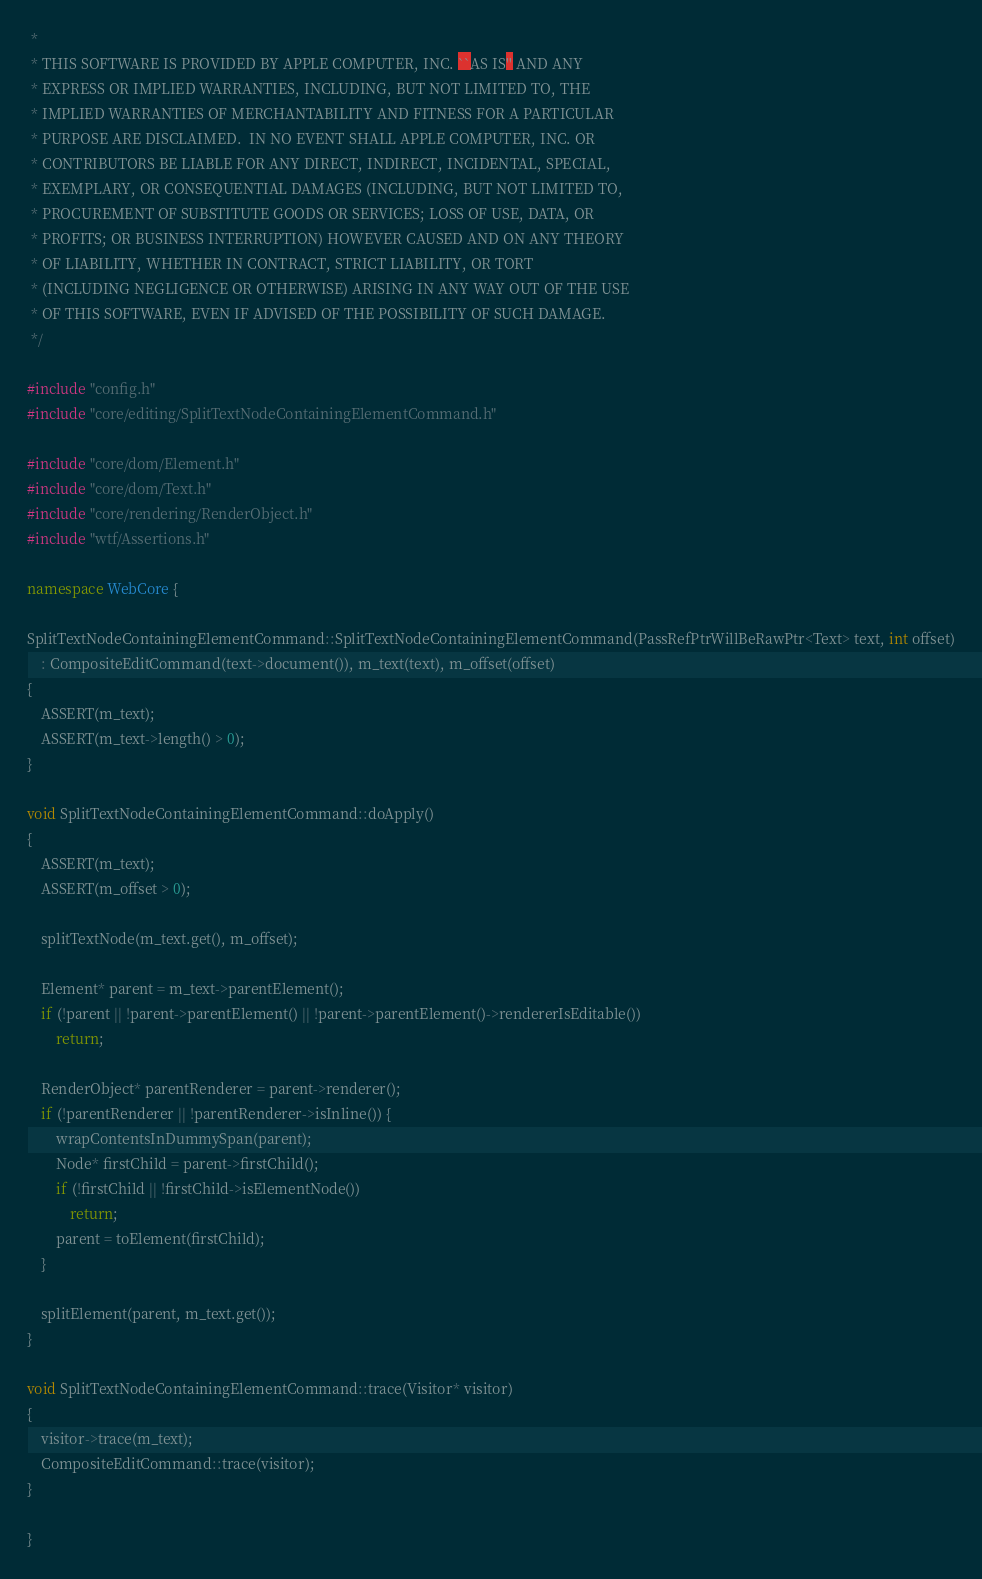<code> <loc_0><loc_0><loc_500><loc_500><_C++_> *
 * THIS SOFTWARE IS PROVIDED BY APPLE COMPUTER, INC. ``AS IS'' AND ANY
 * EXPRESS OR IMPLIED WARRANTIES, INCLUDING, BUT NOT LIMITED TO, THE
 * IMPLIED WARRANTIES OF MERCHANTABILITY AND FITNESS FOR A PARTICULAR
 * PURPOSE ARE DISCLAIMED.  IN NO EVENT SHALL APPLE COMPUTER, INC. OR
 * CONTRIBUTORS BE LIABLE FOR ANY DIRECT, INDIRECT, INCIDENTAL, SPECIAL,
 * EXEMPLARY, OR CONSEQUENTIAL DAMAGES (INCLUDING, BUT NOT LIMITED TO,
 * PROCUREMENT OF SUBSTITUTE GOODS OR SERVICES; LOSS OF USE, DATA, OR
 * PROFITS; OR BUSINESS INTERRUPTION) HOWEVER CAUSED AND ON ANY THEORY
 * OF LIABILITY, WHETHER IN CONTRACT, STRICT LIABILITY, OR TORT
 * (INCLUDING NEGLIGENCE OR OTHERWISE) ARISING IN ANY WAY OUT OF THE USE
 * OF THIS SOFTWARE, EVEN IF ADVISED OF THE POSSIBILITY OF SUCH DAMAGE.
 */

#include "config.h"
#include "core/editing/SplitTextNodeContainingElementCommand.h"

#include "core/dom/Element.h"
#include "core/dom/Text.h"
#include "core/rendering/RenderObject.h"
#include "wtf/Assertions.h"

namespace WebCore {

SplitTextNodeContainingElementCommand::SplitTextNodeContainingElementCommand(PassRefPtrWillBeRawPtr<Text> text, int offset)
    : CompositeEditCommand(text->document()), m_text(text), m_offset(offset)
{
    ASSERT(m_text);
    ASSERT(m_text->length() > 0);
}

void SplitTextNodeContainingElementCommand::doApply()
{
    ASSERT(m_text);
    ASSERT(m_offset > 0);

    splitTextNode(m_text.get(), m_offset);

    Element* parent = m_text->parentElement();
    if (!parent || !parent->parentElement() || !parent->parentElement()->rendererIsEditable())
        return;

    RenderObject* parentRenderer = parent->renderer();
    if (!parentRenderer || !parentRenderer->isInline()) {
        wrapContentsInDummySpan(parent);
        Node* firstChild = parent->firstChild();
        if (!firstChild || !firstChild->isElementNode())
            return;
        parent = toElement(firstChild);
    }

    splitElement(parent, m_text.get());
}

void SplitTextNodeContainingElementCommand::trace(Visitor* visitor)
{
    visitor->trace(m_text);
    CompositeEditCommand::trace(visitor);
}

}
</code> 